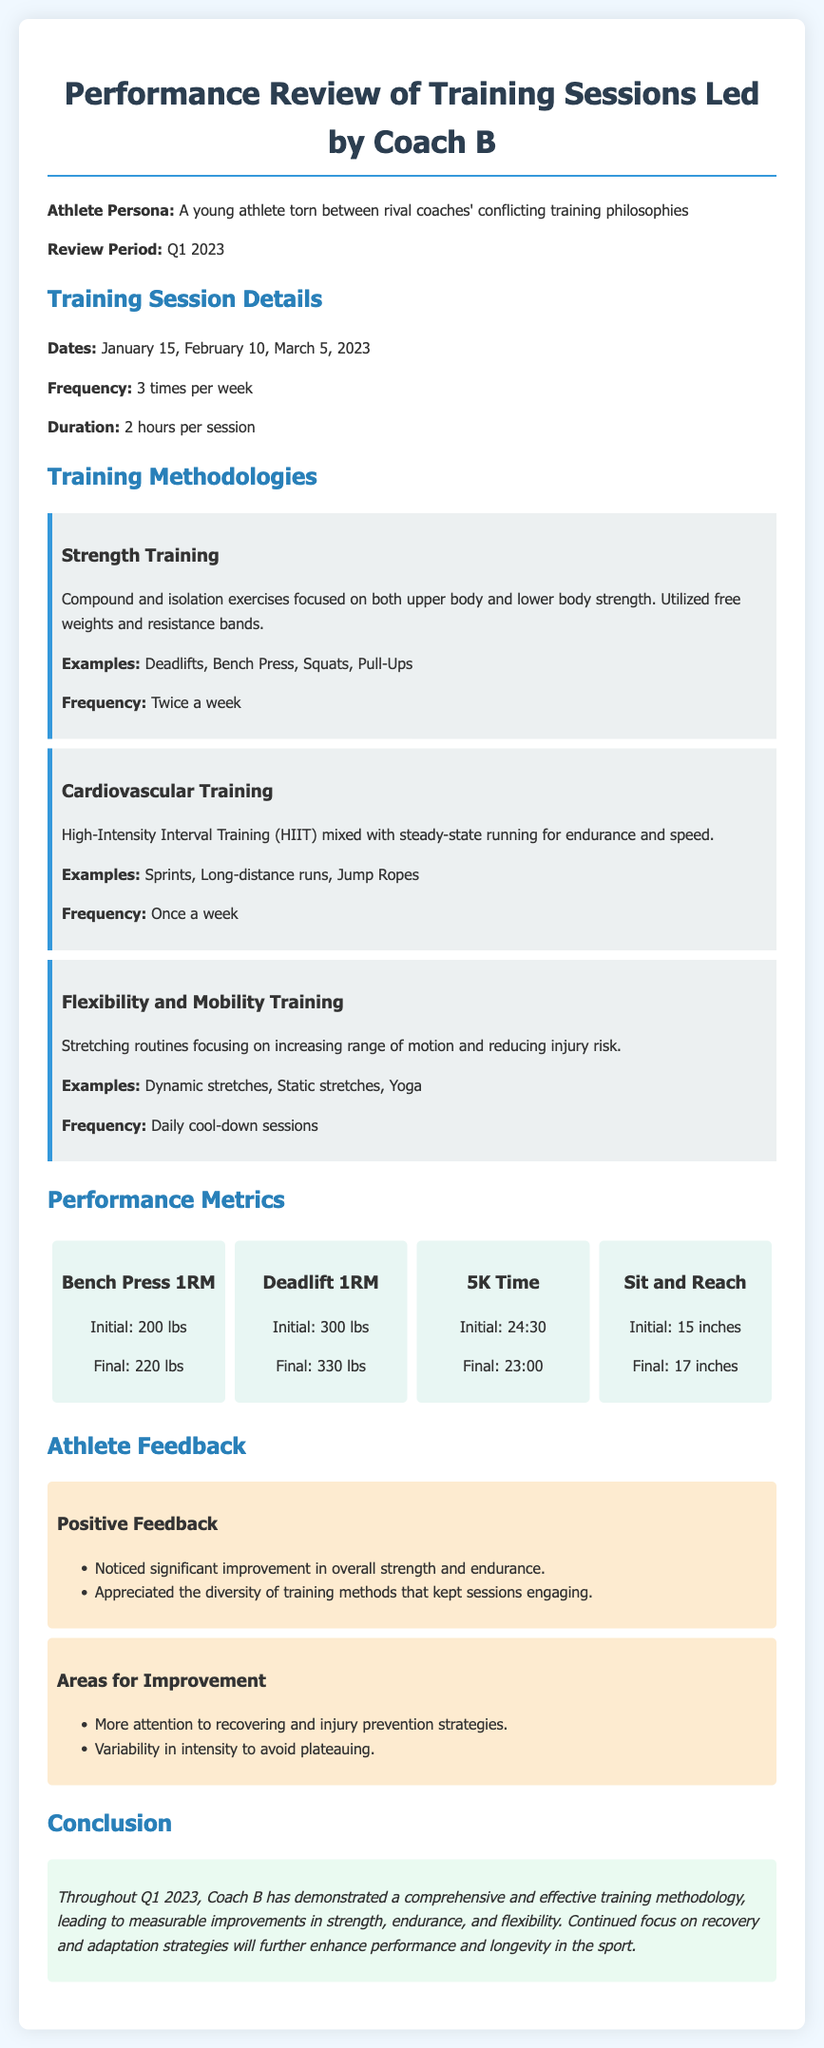What were the training session dates? The training session dates are listed in the document as January 15, February 10, March 5, 2023.
Answer: January 15, February 10, March 5, 2023 How many training sessions were held per week? The frequency of training sessions is explicitly mentioned in the document as three times per week.
Answer: 3 times per week What is the initial Bench Press 1RM? The initial Bench Press 1RM is found in the Performance Metrics section, which states it was 200 lbs.
Answer: 200 lbs Which method was used for cardiovascular training? Cardiovascular training methodology is described as High-Intensity Interval Training mixed with steady-state running.
Answer: High-Intensity Interval Training What was the initial 5K time? The initial 5K time is provided in the document under Performance Metrics, which states it was 24:30.
Answer: 24:30 What improvement was noted in the Sit and Reach measurement? The Sit and Reach initial and final measurements show progress from 15 inches to 17 inches, indicating improvement.
Answer: 2 inches What training frequency is allocated for flexibility and mobility training? The document indicates flexibility and mobility training sessions are held daily for cool-down.
Answer: Daily What area did the athlete feel needed improvement? The athlete highlighted that more attention to recovering and injury prevention strategies was needed.
Answer: Recovering and injury prevention What was the conclusion about Coach B's training methodology? The conclusion summarizes that Coach B demonstrated a comprehensive and effective training methodology throughout Q1 2023.
Answer: Comprehensive and effective 